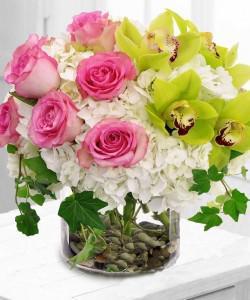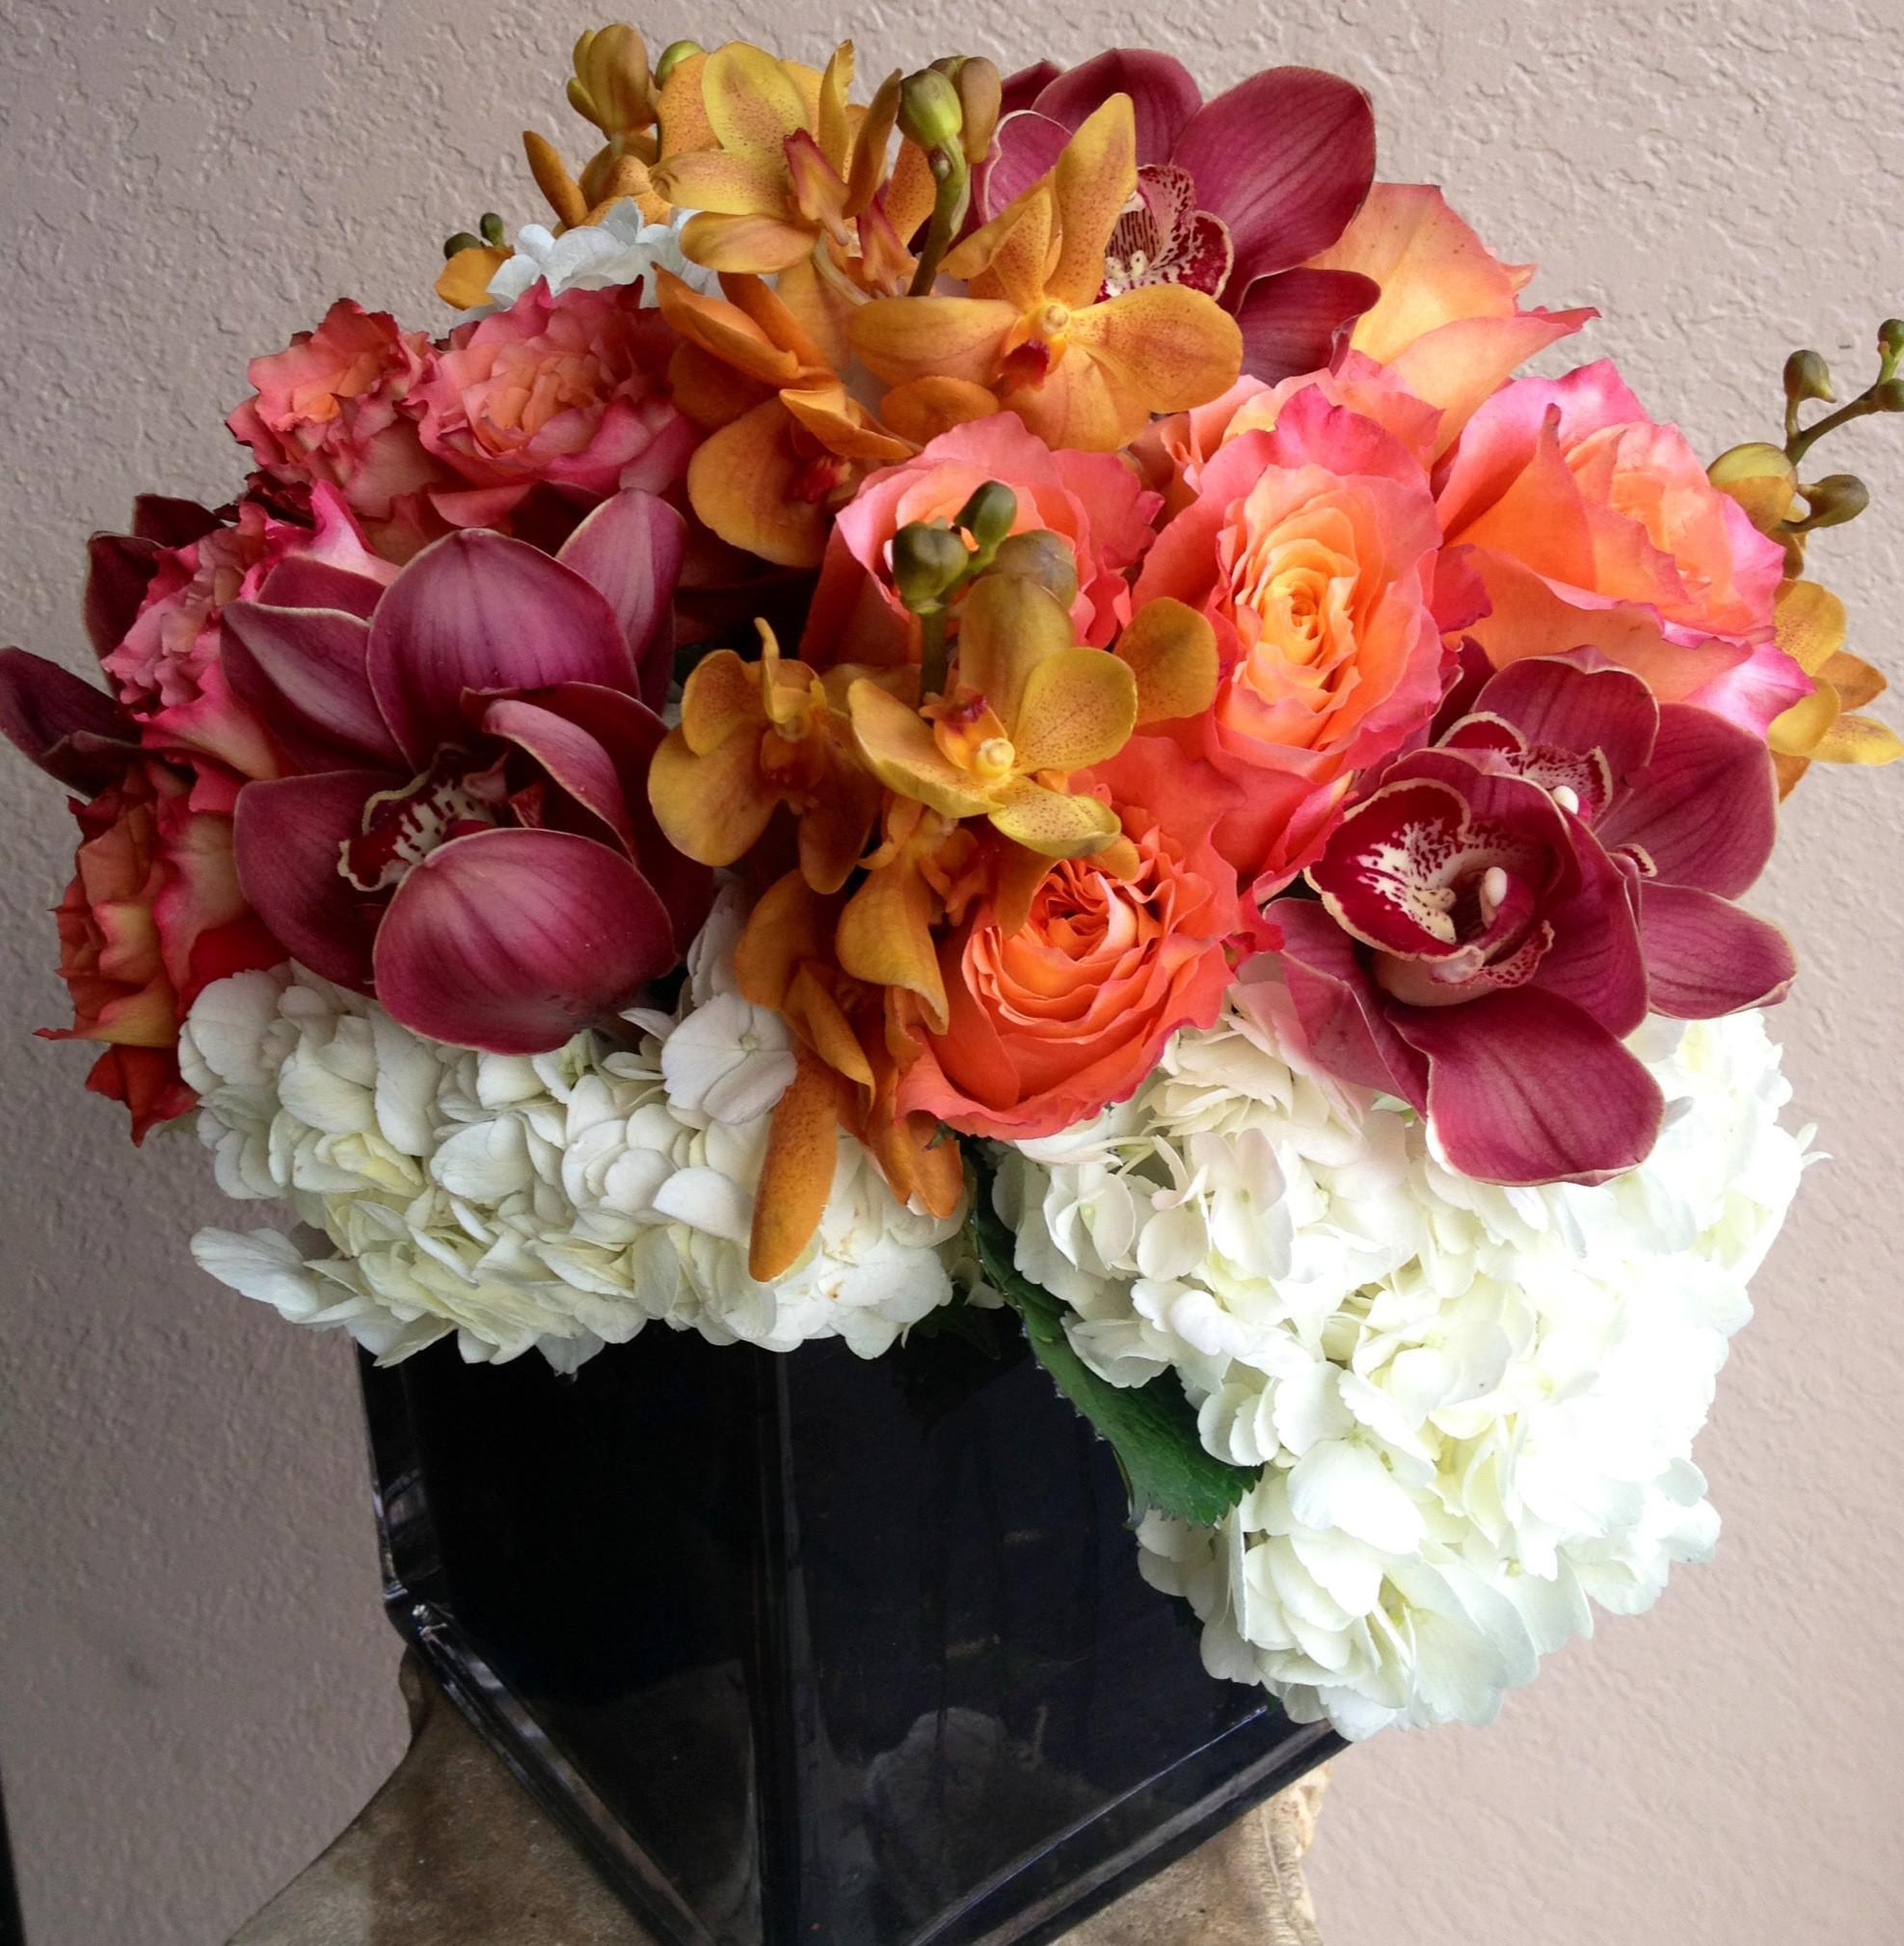The first image is the image on the left, the second image is the image on the right. Given the left and right images, does the statement "One image shows a transparent cylindrical vase with pebble-shaped objects inside, holding a bouquet of pink roses and ruffly white flowers." hold true? Answer yes or no. Yes. The first image is the image on the left, the second image is the image on the right. Considering the images on both sides, is "There are stones at the bottom of one of the vases." valid? Answer yes or no. Yes. 